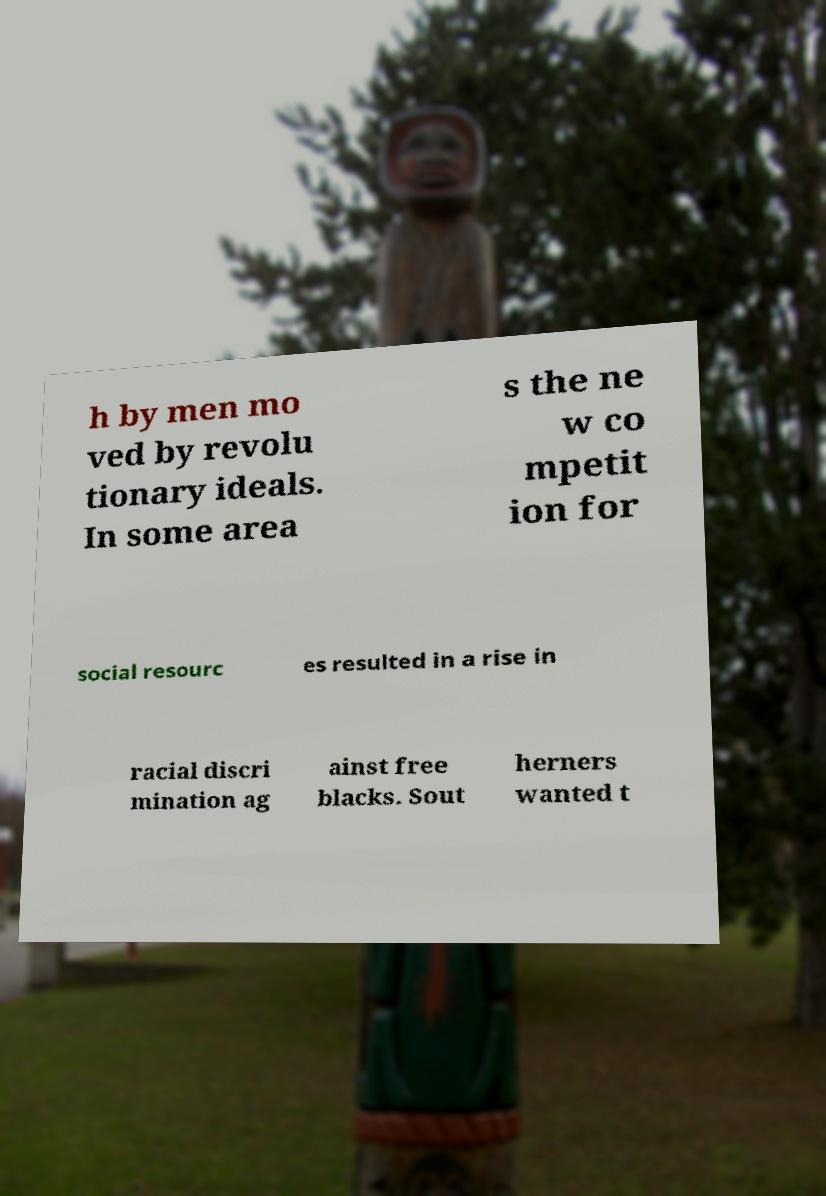Can you read and provide the text displayed in the image?This photo seems to have some interesting text. Can you extract and type it out for me? h by men mo ved by revolu tionary ideals. In some area s the ne w co mpetit ion for social resourc es resulted in a rise in racial discri mination ag ainst free blacks. Sout herners wanted t 